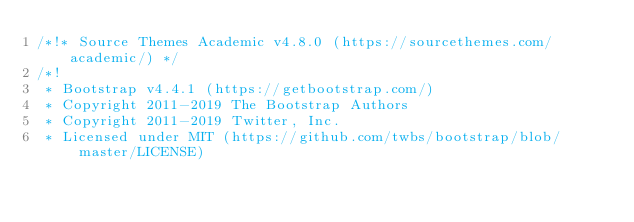<code> <loc_0><loc_0><loc_500><loc_500><_CSS_>/*!* Source Themes Academic v4.8.0 (https://sourcethemes.com/academic/) */
/*!
 * Bootstrap v4.4.1 (https://getbootstrap.com/)
 * Copyright 2011-2019 The Bootstrap Authors
 * Copyright 2011-2019 Twitter, Inc.
 * Licensed under MIT (https://github.com/twbs/bootstrap/blob/master/LICENSE)</code> 